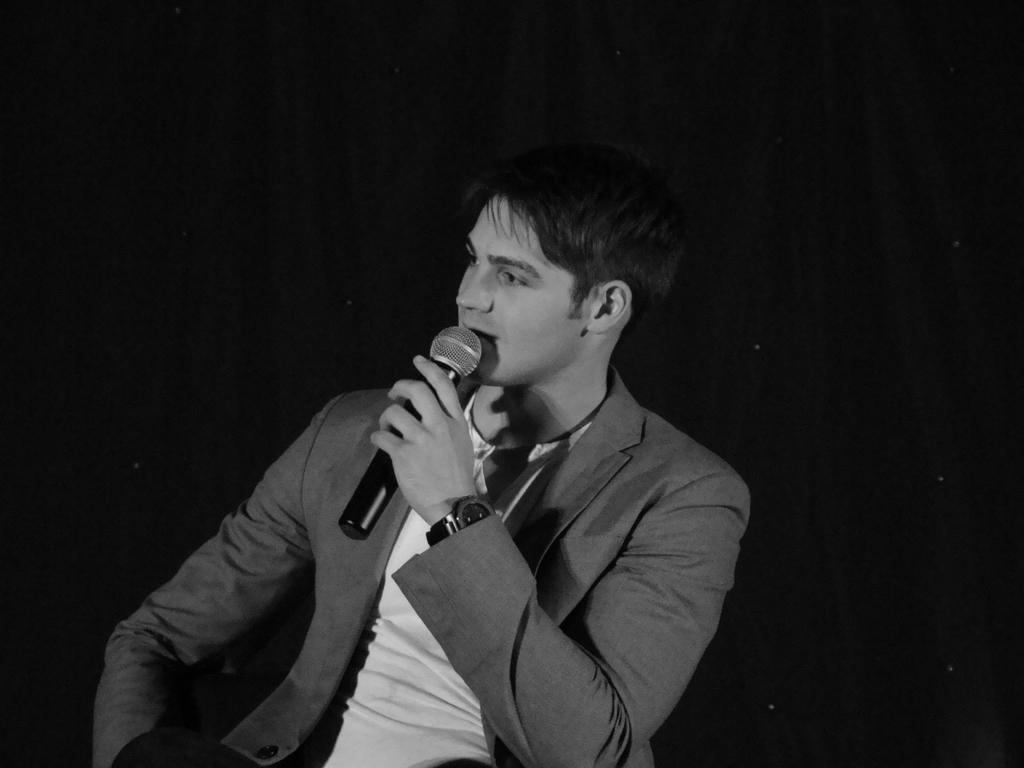What is the man in the image doing? The man is sitting in the image. What object is the man holding? The man is holding a microphone. What can be seen in the background of the image? There is a screen visible in the background of the image. What type of polish is the man applying to his face in the image? There is no indication in the image that the man is applying any polish to his face. 